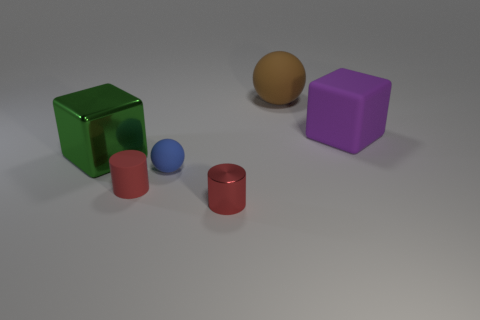Subtract all green blocks. How many blocks are left? 1 Subtract all cylinders. How many objects are left? 4 Add 2 big purple objects. How many objects exist? 8 Subtract all big cyan shiny objects. Subtract all big rubber objects. How many objects are left? 4 Add 5 metal objects. How many metal objects are left? 7 Add 4 purple blocks. How many purple blocks exist? 5 Subtract 0 green cylinders. How many objects are left? 6 Subtract 2 spheres. How many spheres are left? 0 Subtract all red spheres. Subtract all brown blocks. How many spheres are left? 2 Subtract all blue cubes. How many cyan cylinders are left? 0 